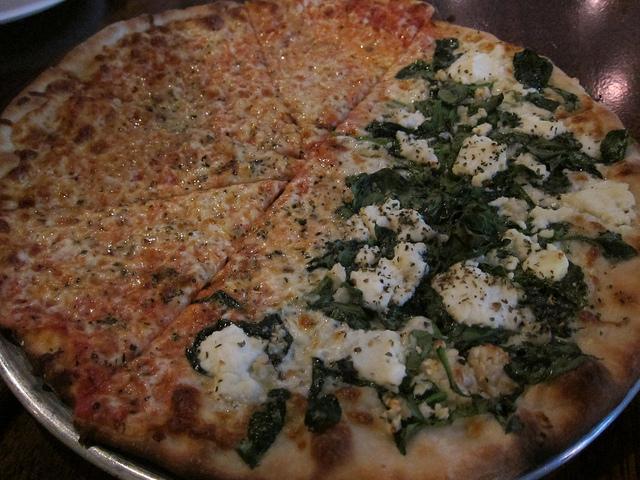How many pizzas can be seen?
Give a very brief answer. 1. 